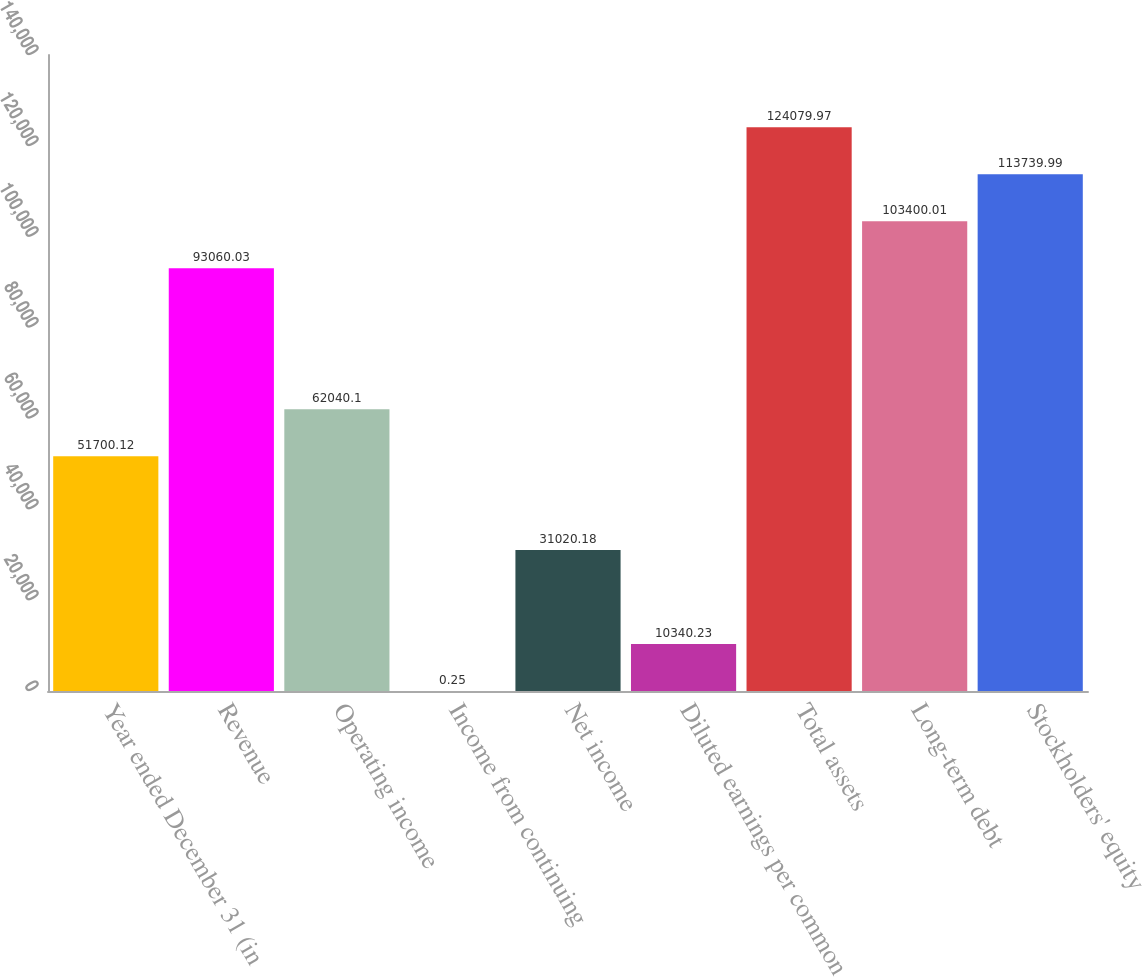Convert chart to OTSL. <chart><loc_0><loc_0><loc_500><loc_500><bar_chart><fcel>Year ended December 31 (in<fcel>Revenue<fcel>Operating income<fcel>Income from continuing<fcel>Net income<fcel>Diluted earnings per common<fcel>Total assets<fcel>Long-term debt<fcel>Stockholders' equity<nl><fcel>51700.1<fcel>93060<fcel>62040.1<fcel>0.25<fcel>31020.2<fcel>10340.2<fcel>124080<fcel>103400<fcel>113740<nl></chart> 